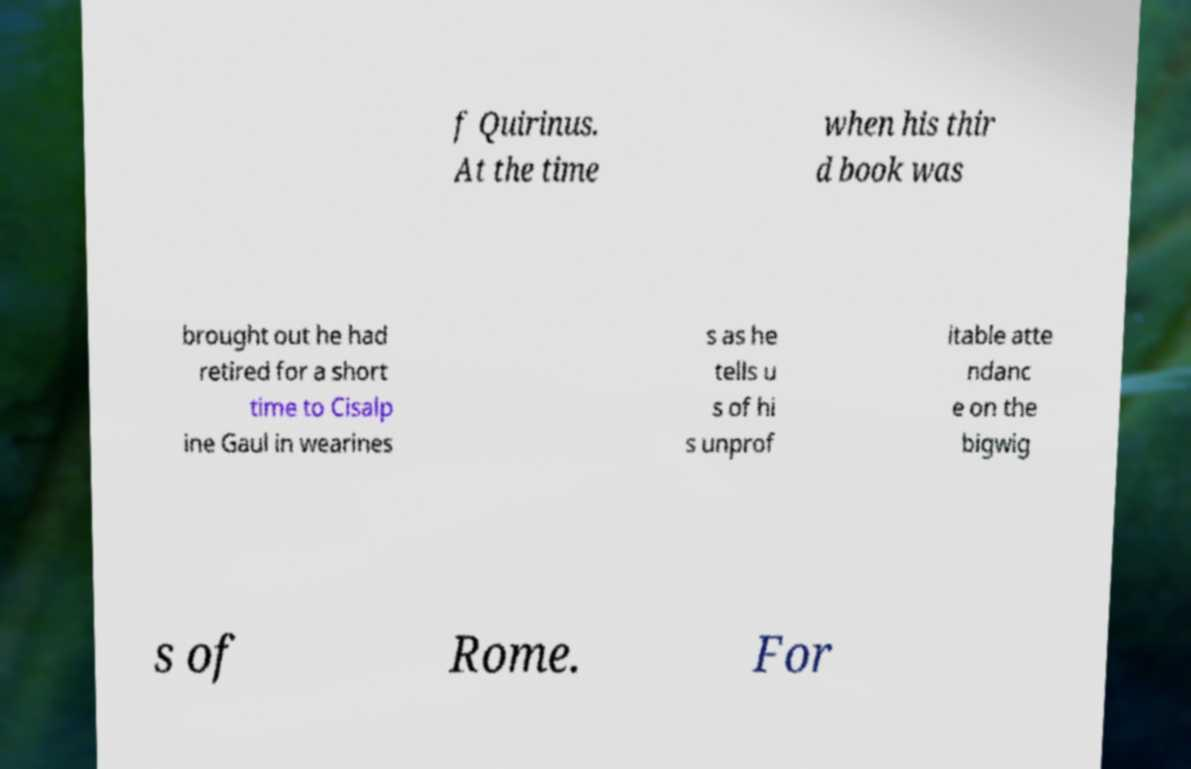Could you extract and type out the text from this image? f Quirinus. At the time when his thir d book was brought out he had retired for a short time to Cisalp ine Gaul in wearines s as he tells u s of hi s unprof itable atte ndanc e on the bigwig s of Rome. For 